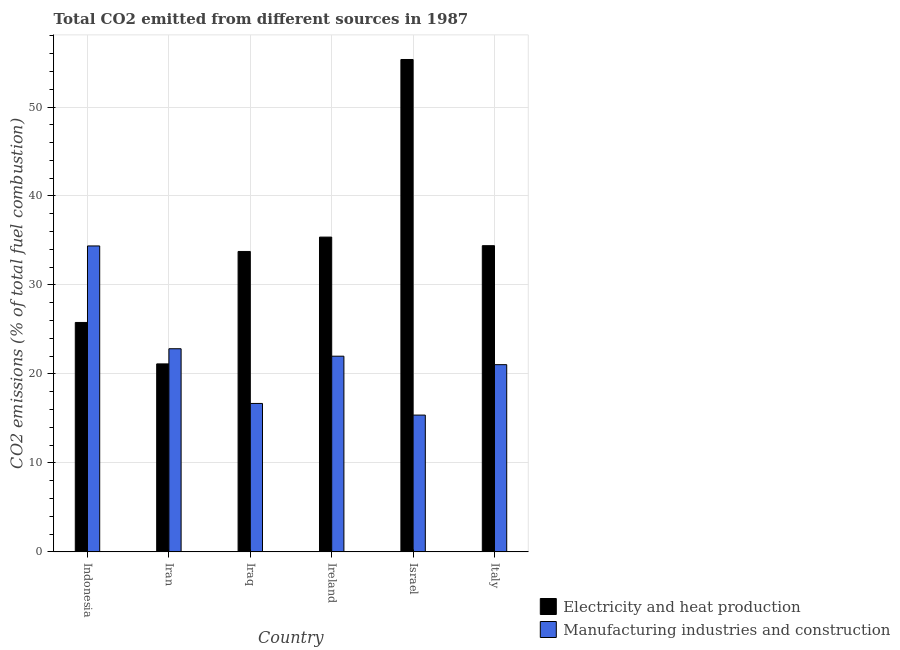How many groups of bars are there?
Provide a succinct answer. 6. Are the number of bars on each tick of the X-axis equal?
Your answer should be very brief. Yes. How many bars are there on the 3rd tick from the left?
Your response must be concise. 2. How many bars are there on the 4th tick from the right?
Provide a succinct answer. 2. What is the label of the 2nd group of bars from the left?
Your answer should be very brief. Iran. In how many cases, is the number of bars for a given country not equal to the number of legend labels?
Offer a terse response. 0. What is the co2 emissions due to manufacturing industries in Italy?
Your answer should be very brief. 21.04. Across all countries, what is the maximum co2 emissions due to manufacturing industries?
Your answer should be very brief. 34.38. Across all countries, what is the minimum co2 emissions due to manufacturing industries?
Provide a succinct answer. 15.37. What is the total co2 emissions due to manufacturing industries in the graph?
Provide a short and direct response. 132.31. What is the difference between the co2 emissions due to manufacturing industries in Iran and that in Italy?
Provide a short and direct response. 1.79. What is the difference between the co2 emissions due to electricity and heat production in Israel and the co2 emissions due to manufacturing industries in Indonesia?
Your answer should be very brief. 20.96. What is the average co2 emissions due to manufacturing industries per country?
Give a very brief answer. 22.05. What is the difference between the co2 emissions due to electricity and heat production and co2 emissions due to manufacturing industries in Israel?
Make the answer very short. 39.97. In how many countries, is the co2 emissions due to manufacturing industries greater than 12 %?
Ensure brevity in your answer.  6. What is the ratio of the co2 emissions due to manufacturing industries in Israel to that in Italy?
Offer a very short reply. 0.73. Is the difference between the co2 emissions due to manufacturing industries in Iraq and Ireland greater than the difference between the co2 emissions due to electricity and heat production in Iraq and Ireland?
Offer a terse response. No. What is the difference between the highest and the second highest co2 emissions due to electricity and heat production?
Give a very brief answer. 19.96. What is the difference between the highest and the lowest co2 emissions due to electricity and heat production?
Provide a succinct answer. 34.21. Is the sum of the co2 emissions due to manufacturing industries in Iran and Ireland greater than the maximum co2 emissions due to electricity and heat production across all countries?
Your answer should be compact. No. What does the 1st bar from the left in Iraq represents?
Offer a terse response. Electricity and heat production. What does the 2nd bar from the right in Israel represents?
Your answer should be very brief. Electricity and heat production. How many countries are there in the graph?
Your response must be concise. 6. What is the difference between two consecutive major ticks on the Y-axis?
Offer a terse response. 10. Does the graph contain any zero values?
Give a very brief answer. No. Where does the legend appear in the graph?
Give a very brief answer. Bottom right. How many legend labels are there?
Provide a short and direct response. 2. How are the legend labels stacked?
Keep it short and to the point. Vertical. What is the title of the graph?
Give a very brief answer. Total CO2 emitted from different sources in 1987. What is the label or title of the Y-axis?
Give a very brief answer. CO2 emissions (% of total fuel combustion). What is the CO2 emissions (% of total fuel combustion) in Electricity and heat production in Indonesia?
Your answer should be very brief. 25.79. What is the CO2 emissions (% of total fuel combustion) of Manufacturing industries and construction in Indonesia?
Your answer should be very brief. 34.38. What is the CO2 emissions (% of total fuel combustion) in Electricity and heat production in Iran?
Provide a short and direct response. 21.13. What is the CO2 emissions (% of total fuel combustion) of Manufacturing industries and construction in Iran?
Provide a short and direct response. 22.83. What is the CO2 emissions (% of total fuel combustion) of Electricity and heat production in Iraq?
Make the answer very short. 33.77. What is the CO2 emissions (% of total fuel combustion) in Manufacturing industries and construction in Iraq?
Your answer should be very brief. 16.68. What is the CO2 emissions (% of total fuel combustion) of Electricity and heat production in Ireland?
Provide a succinct answer. 35.38. What is the CO2 emissions (% of total fuel combustion) in Manufacturing industries and construction in Ireland?
Provide a short and direct response. 21.99. What is the CO2 emissions (% of total fuel combustion) in Electricity and heat production in Israel?
Offer a very short reply. 55.34. What is the CO2 emissions (% of total fuel combustion) in Manufacturing industries and construction in Israel?
Give a very brief answer. 15.37. What is the CO2 emissions (% of total fuel combustion) of Electricity and heat production in Italy?
Make the answer very short. 34.41. What is the CO2 emissions (% of total fuel combustion) of Manufacturing industries and construction in Italy?
Your answer should be very brief. 21.04. Across all countries, what is the maximum CO2 emissions (% of total fuel combustion) of Electricity and heat production?
Your answer should be compact. 55.34. Across all countries, what is the maximum CO2 emissions (% of total fuel combustion) of Manufacturing industries and construction?
Give a very brief answer. 34.38. Across all countries, what is the minimum CO2 emissions (% of total fuel combustion) of Electricity and heat production?
Your answer should be compact. 21.13. Across all countries, what is the minimum CO2 emissions (% of total fuel combustion) of Manufacturing industries and construction?
Offer a very short reply. 15.37. What is the total CO2 emissions (% of total fuel combustion) of Electricity and heat production in the graph?
Your answer should be compact. 205.81. What is the total CO2 emissions (% of total fuel combustion) of Manufacturing industries and construction in the graph?
Provide a succinct answer. 132.31. What is the difference between the CO2 emissions (% of total fuel combustion) in Electricity and heat production in Indonesia and that in Iran?
Make the answer very short. 4.66. What is the difference between the CO2 emissions (% of total fuel combustion) in Manufacturing industries and construction in Indonesia and that in Iran?
Offer a very short reply. 11.55. What is the difference between the CO2 emissions (% of total fuel combustion) in Electricity and heat production in Indonesia and that in Iraq?
Make the answer very short. -7.98. What is the difference between the CO2 emissions (% of total fuel combustion) of Manufacturing industries and construction in Indonesia and that in Iraq?
Provide a short and direct response. 17.7. What is the difference between the CO2 emissions (% of total fuel combustion) of Electricity and heat production in Indonesia and that in Ireland?
Offer a terse response. -9.59. What is the difference between the CO2 emissions (% of total fuel combustion) of Manufacturing industries and construction in Indonesia and that in Ireland?
Your answer should be compact. 12.39. What is the difference between the CO2 emissions (% of total fuel combustion) of Electricity and heat production in Indonesia and that in Israel?
Provide a short and direct response. -29.55. What is the difference between the CO2 emissions (% of total fuel combustion) of Manufacturing industries and construction in Indonesia and that in Israel?
Provide a succinct answer. 19.01. What is the difference between the CO2 emissions (% of total fuel combustion) in Electricity and heat production in Indonesia and that in Italy?
Provide a succinct answer. -8.63. What is the difference between the CO2 emissions (% of total fuel combustion) of Manufacturing industries and construction in Indonesia and that in Italy?
Your answer should be compact. 13.34. What is the difference between the CO2 emissions (% of total fuel combustion) in Electricity and heat production in Iran and that in Iraq?
Provide a short and direct response. -12.64. What is the difference between the CO2 emissions (% of total fuel combustion) in Manufacturing industries and construction in Iran and that in Iraq?
Give a very brief answer. 6.15. What is the difference between the CO2 emissions (% of total fuel combustion) in Electricity and heat production in Iran and that in Ireland?
Make the answer very short. -14.25. What is the difference between the CO2 emissions (% of total fuel combustion) in Manufacturing industries and construction in Iran and that in Ireland?
Offer a terse response. 0.84. What is the difference between the CO2 emissions (% of total fuel combustion) in Electricity and heat production in Iran and that in Israel?
Your answer should be very brief. -34.21. What is the difference between the CO2 emissions (% of total fuel combustion) of Manufacturing industries and construction in Iran and that in Israel?
Your response must be concise. 7.46. What is the difference between the CO2 emissions (% of total fuel combustion) in Electricity and heat production in Iran and that in Italy?
Ensure brevity in your answer.  -13.29. What is the difference between the CO2 emissions (% of total fuel combustion) of Manufacturing industries and construction in Iran and that in Italy?
Your answer should be very brief. 1.79. What is the difference between the CO2 emissions (% of total fuel combustion) in Electricity and heat production in Iraq and that in Ireland?
Your answer should be compact. -1.61. What is the difference between the CO2 emissions (% of total fuel combustion) in Manufacturing industries and construction in Iraq and that in Ireland?
Your response must be concise. -5.31. What is the difference between the CO2 emissions (% of total fuel combustion) of Electricity and heat production in Iraq and that in Israel?
Ensure brevity in your answer.  -21.58. What is the difference between the CO2 emissions (% of total fuel combustion) of Manufacturing industries and construction in Iraq and that in Israel?
Provide a short and direct response. 1.31. What is the difference between the CO2 emissions (% of total fuel combustion) in Electricity and heat production in Iraq and that in Italy?
Provide a short and direct response. -0.65. What is the difference between the CO2 emissions (% of total fuel combustion) of Manufacturing industries and construction in Iraq and that in Italy?
Keep it short and to the point. -4.36. What is the difference between the CO2 emissions (% of total fuel combustion) in Electricity and heat production in Ireland and that in Israel?
Your response must be concise. -19.96. What is the difference between the CO2 emissions (% of total fuel combustion) in Manufacturing industries and construction in Ireland and that in Israel?
Your answer should be compact. 6.62. What is the difference between the CO2 emissions (% of total fuel combustion) in Electricity and heat production in Ireland and that in Italy?
Provide a succinct answer. 0.96. What is the difference between the CO2 emissions (% of total fuel combustion) in Manufacturing industries and construction in Ireland and that in Italy?
Ensure brevity in your answer.  0.95. What is the difference between the CO2 emissions (% of total fuel combustion) of Electricity and heat production in Israel and that in Italy?
Your response must be concise. 20.93. What is the difference between the CO2 emissions (% of total fuel combustion) in Manufacturing industries and construction in Israel and that in Italy?
Provide a short and direct response. -5.67. What is the difference between the CO2 emissions (% of total fuel combustion) of Electricity and heat production in Indonesia and the CO2 emissions (% of total fuel combustion) of Manufacturing industries and construction in Iran?
Provide a succinct answer. 2.95. What is the difference between the CO2 emissions (% of total fuel combustion) in Electricity and heat production in Indonesia and the CO2 emissions (% of total fuel combustion) in Manufacturing industries and construction in Iraq?
Your answer should be compact. 9.1. What is the difference between the CO2 emissions (% of total fuel combustion) in Electricity and heat production in Indonesia and the CO2 emissions (% of total fuel combustion) in Manufacturing industries and construction in Ireland?
Your answer should be compact. 3.79. What is the difference between the CO2 emissions (% of total fuel combustion) in Electricity and heat production in Indonesia and the CO2 emissions (% of total fuel combustion) in Manufacturing industries and construction in Israel?
Your response must be concise. 10.41. What is the difference between the CO2 emissions (% of total fuel combustion) of Electricity and heat production in Indonesia and the CO2 emissions (% of total fuel combustion) of Manufacturing industries and construction in Italy?
Keep it short and to the point. 4.74. What is the difference between the CO2 emissions (% of total fuel combustion) of Electricity and heat production in Iran and the CO2 emissions (% of total fuel combustion) of Manufacturing industries and construction in Iraq?
Keep it short and to the point. 4.45. What is the difference between the CO2 emissions (% of total fuel combustion) of Electricity and heat production in Iran and the CO2 emissions (% of total fuel combustion) of Manufacturing industries and construction in Ireland?
Your response must be concise. -0.87. What is the difference between the CO2 emissions (% of total fuel combustion) of Electricity and heat production in Iran and the CO2 emissions (% of total fuel combustion) of Manufacturing industries and construction in Israel?
Provide a short and direct response. 5.75. What is the difference between the CO2 emissions (% of total fuel combustion) in Electricity and heat production in Iran and the CO2 emissions (% of total fuel combustion) in Manufacturing industries and construction in Italy?
Make the answer very short. 0.09. What is the difference between the CO2 emissions (% of total fuel combustion) in Electricity and heat production in Iraq and the CO2 emissions (% of total fuel combustion) in Manufacturing industries and construction in Ireland?
Provide a succinct answer. 11.77. What is the difference between the CO2 emissions (% of total fuel combustion) in Electricity and heat production in Iraq and the CO2 emissions (% of total fuel combustion) in Manufacturing industries and construction in Israel?
Your answer should be compact. 18.39. What is the difference between the CO2 emissions (% of total fuel combustion) in Electricity and heat production in Iraq and the CO2 emissions (% of total fuel combustion) in Manufacturing industries and construction in Italy?
Give a very brief answer. 12.72. What is the difference between the CO2 emissions (% of total fuel combustion) of Electricity and heat production in Ireland and the CO2 emissions (% of total fuel combustion) of Manufacturing industries and construction in Israel?
Offer a terse response. 20. What is the difference between the CO2 emissions (% of total fuel combustion) in Electricity and heat production in Ireland and the CO2 emissions (% of total fuel combustion) in Manufacturing industries and construction in Italy?
Make the answer very short. 14.34. What is the difference between the CO2 emissions (% of total fuel combustion) of Electricity and heat production in Israel and the CO2 emissions (% of total fuel combustion) of Manufacturing industries and construction in Italy?
Make the answer very short. 34.3. What is the average CO2 emissions (% of total fuel combustion) in Electricity and heat production per country?
Offer a terse response. 34.3. What is the average CO2 emissions (% of total fuel combustion) in Manufacturing industries and construction per country?
Offer a very short reply. 22.05. What is the difference between the CO2 emissions (% of total fuel combustion) of Electricity and heat production and CO2 emissions (% of total fuel combustion) of Manufacturing industries and construction in Indonesia?
Give a very brief answer. -8.6. What is the difference between the CO2 emissions (% of total fuel combustion) of Electricity and heat production and CO2 emissions (% of total fuel combustion) of Manufacturing industries and construction in Iran?
Your response must be concise. -1.7. What is the difference between the CO2 emissions (% of total fuel combustion) in Electricity and heat production and CO2 emissions (% of total fuel combustion) in Manufacturing industries and construction in Iraq?
Provide a short and direct response. 17.08. What is the difference between the CO2 emissions (% of total fuel combustion) of Electricity and heat production and CO2 emissions (% of total fuel combustion) of Manufacturing industries and construction in Ireland?
Your response must be concise. 13.39. What is the difference between the CO2 emissions (% of total fuel combustion) of Electricity and heat production and CO2 emissions (% of total fuel combustion) of Manufacturing industries and construction in Israel?
Your answer should be compact. 39.97. What is the difference between the CO2 emissions (% of total fuel combustion) of Electricity and heat production and CO2 emissions (% of total fuel combustion) of Manufacturing industries and construction in Italy?
Your response must be concise. 13.37. What is the ratio of the CO2 emissions (% of total fuel combustion) in Electricity and heat production in Indonesia to that in Iran?
Give a very brief answer. 1.22. What is the ratio of the CO2 emissions (% of total fuel combustion) of Manufacturing industries and construction in Indonesia to that in Iran?
Make the answer very short. 1.51. What is the ratio of the CO2 emissions (% of total fuel combustion) of Electricity and heat production in Indonesia to that in Iraq?
Your response must be concise. 0.76. What is the ratio of the CO2 emissions (% of total fuel combustion) in Manufacturing industries and construction in Indonesia to that in Iraq?
Provide a short and direct response. 2.06. What is the ratio of the CO2 emissions (% of total fuel combustion) in Electricity and heat production in Indonesia to that in Ireland?
Your answer should be very brief. 0.73. What is the ratio of the CO2 emissions (% of total fuel combustion) in Manufacturing industries and construction in Indonesia to that in Ireland?
Offer a very short reply. 1.56. What is the ratio of the CO2 emissions (% of total fuel combustion) in Electricity and heat production in Indonesia to that in Israel?
Provide a succinct answer. 0.47. What is the ratio of the CO2 emissions (% of total fuel combustion) in Manufacturing industries and construction in Indonesia to that in Israel?
Your answer should be very brief. 2.24. What is the ratio of the CO2 emissions (% of total fuel combustion) of Electricity and heat production in Indonesia to that in Italy?
Your response must be concise. 0.75. What is the ratio of the CO2 emissions (% of total fuel combustion) in Manufacturing industries and construction in Indonesia to that in Italy?
Keep it short and to the point. 1.63. What is the ratio of the CO2 emissions (% of total fuel combustion) in Electricity and heat production in Iran to that in Iraq?
Your answer should be very brief. 0.63. What is the ratio of the CO2 emissions (% of total fuel combustion) of Manufacturing industries and construction in Iran to that in Iraq?
Offer a very short reply. 1.37. What is the ratio of the CO2 emissions (% of total fuel combustion) of Electricity and heat production in Iran to that in Ireland?
Offer a very short reply. 0.6. What is the ratio of the CO2 emissions (% of total fuel combustion) in Manufacturing industries and construction in Iran to that in Ireland?
Ensure brevity in your answer.  1.04. What is the ratio of the CO2 emissions (% of total fuel combustion) of Electricity and heat production in Iran to that in Israel?
Offer a terse response. 0.38. What is the ratio of the CO2 emissions (% of total fuel combustion) in Manufacturing industries and construction in Iran to that in Israel?
Make the answer very short. 1.49. What is the ratio of the CO2 emissions (% of total fuel combustion) of Electricity and heat production in Iran to that in Italy?
Offer a very short reply. 0.61. What is the ratio of the CO2 emissions (% of total fuel combustion) of Manufacturing industries and construction in Iran to that in Italy?
Provide a short and direct response. 1.09. What is the ratio of the CO2 emissions (% of total fuel combustion) of Electricity and heat production in Iraq to that in Ireland?
Your response must be concise. 0.95. What is the ratio of the CO2 emissions (% of total fuel combustion) in Manufacturing industries and construction in Iraq to that in Ireland?
Your answer should be compact. 0.76. What is the ratio of the CO2 emissions (% of total fuel combustion) in Electricity and heat production in Iraq to that in Israel?
Offer a terse response. 0.61. What is the ratio of the CO2 emissions (% of total fuel combustion) in Manufacturing industries and construction in Iraq to that in Israel?
Your response must be concise. 1.08. What is the ratio of the CO2 emissions (% of total fuel combustion) in Electricity and heat production in Iraq to that in Italy?
Offer a very short reply. 0.98. What is the ratio of the CO2 emissions (% of total fuel combustion) of Manufacturing industries and construction in Iraq to that in Italy?
Make the answer very short. 0.79. What is the ratio of the CO2 emissions (% of total fuel combustion) in Electricity and heat production in Ireland to that in Israel?
Offer a terse response. 0.64. What is the ratio of the CO2 emissions (% of total fuel combustion) of Manufacturing industries and construction in Ireland to that in Israel?
Your answer should be compact. 1.43. What is the ratio of the CO2 emissions (% of total fuel combustion) of Electricity and heat production in Ireland to that in Italy?
Your answer should be very brief. 1.03. What is the ratio of the CO2 emissions (% of total fuel combustion) in Manufacturing industries and construction in Ireland to that in Italy?
Provide a short and direct response. 1.05. What is the ratio of the CO2 emissions (% of total fuel combustion) in Electricity and heat production in Israel to that in Italy?
Your response must be concise. 1.61. What is the ratio of the CO2 emissions (% of total fuel combustion) in Manufacturing industries and construction in Israel to that in Italy?
Keep it short and to the point. 0.73. What is the difference between the highest and the second highest CO2 emissions (% of total fuel combustion) of Electricity and heat production?
Your answer should be very brief. 19.96. What is the difference between the highest and the second highest CO2 emissions (% of total fuel combustion) of Manufacturing industries and construction?
Give a very brief answer. 11.55. What is the difference between the highest and the lowest CO2 emissions (% of total fuel combustion) in Electricity and heat production?
Your answer should be compact. 34.21. What is the difference between the highest and the lowest CO2 emissions (% of total fuel combustion) in Manufacturing industries and construction?
Offer a terse response. 19.01. 